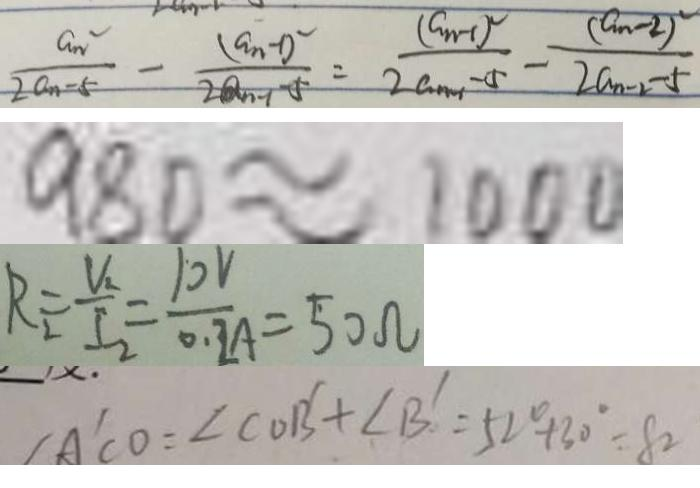<formula> <loc_0><loc_0><loc_500><loc_500>\frac { a n ^ { 2 } } { 2 a n - 5 } - \frac { ( a _ { n - 1 } ) ^ { 2 } } { 2 a _ { n - 1 } - 5 } = \frac { ( a _ { n - 1 } ) ^ { 2 } } { 2 a _ { n - 1 } - 5 } - \frac { ( a _ { n - 2 } ) ^ { 2 } } { 2 a _ { n - 2 } - 5 } 
 9 8 0 \approx 1 0 0 0 
 R _ { 2 } = \frac { V _ { 2 } } { I _ { 2 } } = \frac { 1 0 V } { 0 . 2 A } = 5 0 \Omega 
 \angle A ^ { \prime } C O = \angle C O B ^ { \prime } + \angle B ^ { \prime } = 5 2 ^ { \circ } + 3 0 ^ { \circ } = 8 2</formula> 